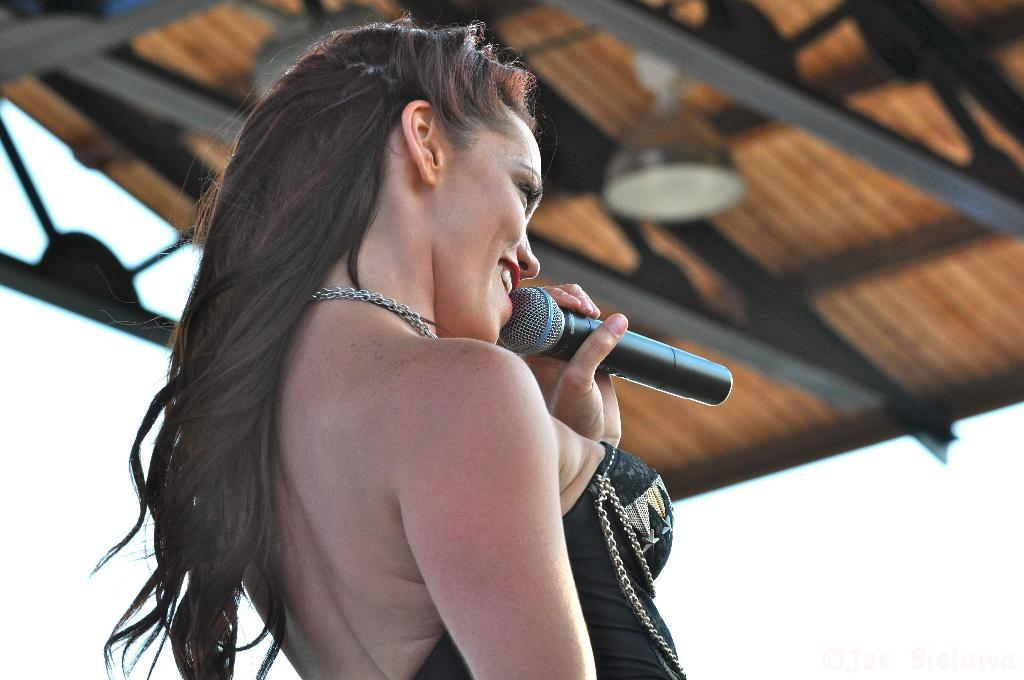Who is the main subject in the image? There is a woman in the image. What is the woman doing in the image? The woman is standing and singing. What object is the woman holding in her hand? The woman is holding a microphone in her hand. What type of bun is the woman wearing in the image? There is no bun visible on the woman's head in the image. What societal impact does the woman's singing have in the image? The image does not provide any information about the societal impact of the woman's singing. 